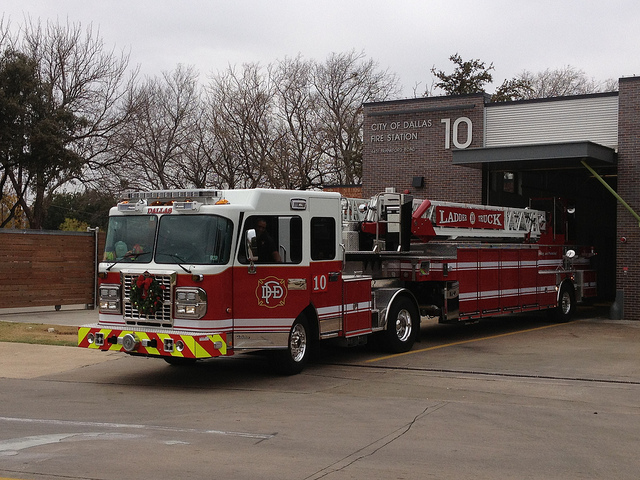Please transcribe the text information in this image. 10 10 DALLAS STATION CITY BUCK LADO OF ARE DE 